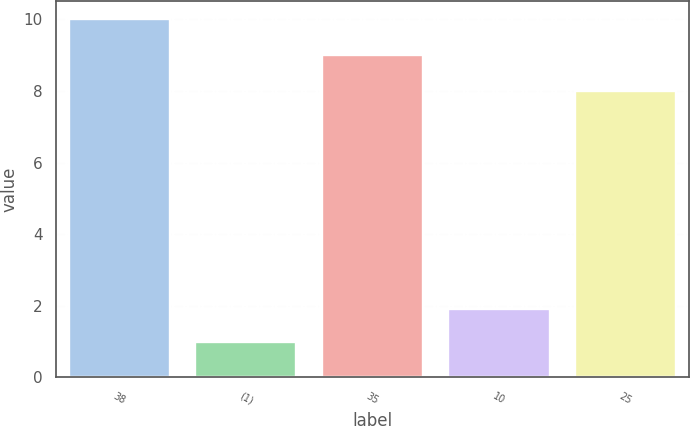Convert chart. <chart><loc_0><loc_0><loc_500><loc_500><bar_chart><fcel>38<fcel>(1)<fcel>35<fcel>10<fcel>25<nl><fcel>10<fcel>1<fcel>9<fcel>1.9<fcel>8<nl></chart> 